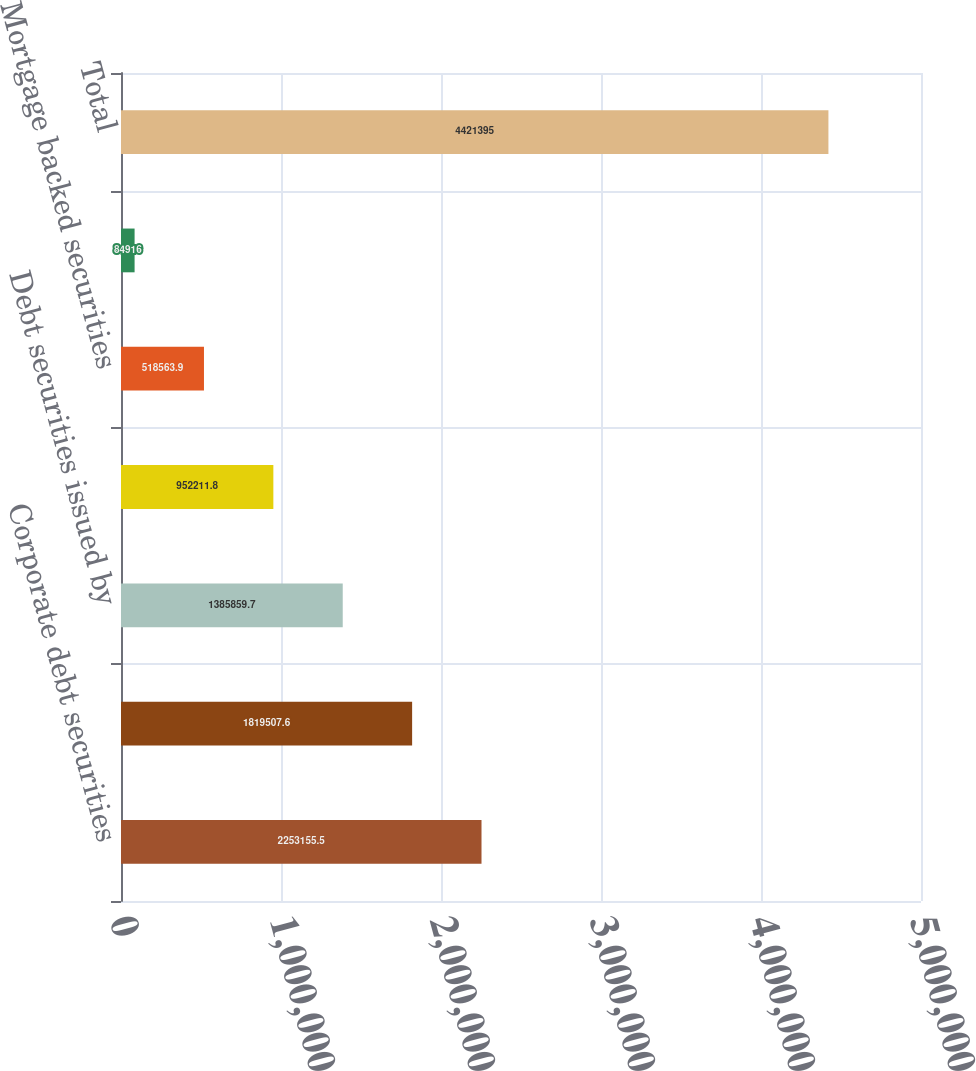Convert chart to OTSL. <chart><loc_0><loc_0><loc_500><loc_500><bar_chart><fcel>Corporate debt securities<fcel>Debt securities of United<fcel>Debt securities issued by<fcel>Asset-backed securities<fcel>Mortgage backed securities<fcel>Foreign government bonds<fcel>Total<nl><fcel>2.25316e+06<fcel>1.81951e+06<fcel>1.38586e+06<fcel>952212<fcel>518564<fcel>84916<fcel>4.4214e+06<nl></chart> 